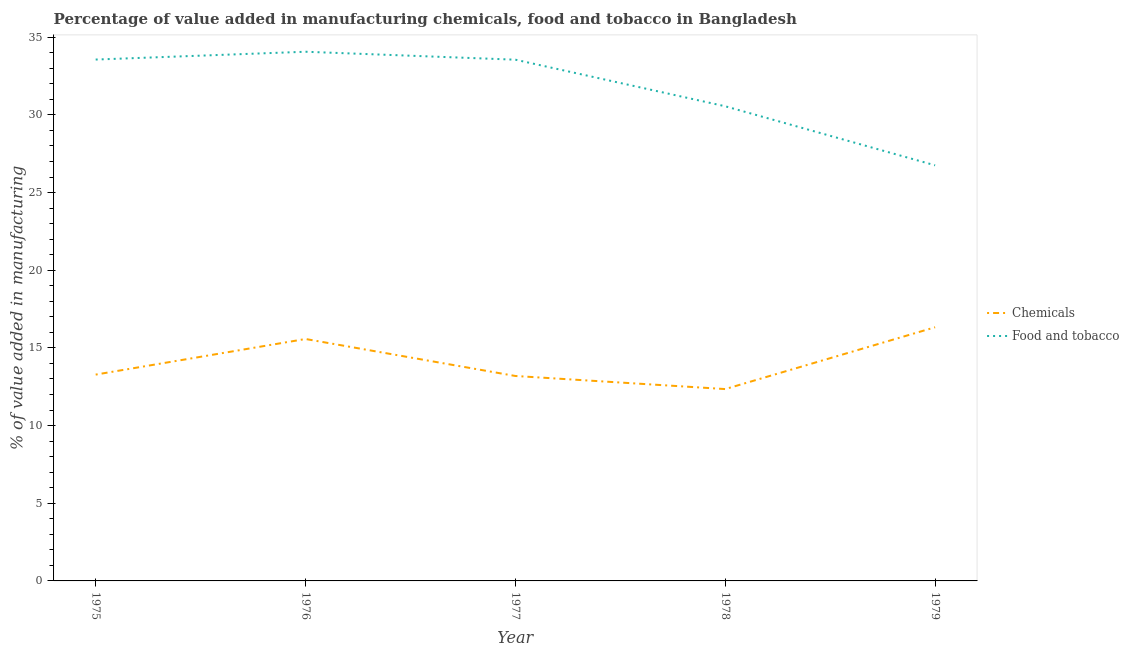What is the value added by  manufacturing chemicals in 1977?
Provide a succinct answer. 13.19. Across all years, what is the maximum value added by manufacturing food and tobacco?
Make the answer very short. 34.07. Across all years, what is the minimum value added by manufacturing food and tobacco?
Your answer should be very brief. 26.75. In which year was the value added by manufacturing food and tobacco maximum?
Your answer should be compact. 1976. In which year was the value added by manufacturing food and tobacco minimum?
Make the answer very short. 1979. What is the total value added by  manufacturing chemicals in the graph?
Provide a succinct answer. 70.73. What is the difference between the value added by manufacturing food and tobacco in 1975 and that in 1978?
Provide a succinct answer. 3.01. What is the difference between the value added by manufacturing food and tobacco in 1978 and the value added by  manufacturing chemicals in 1977?
Your response must be concise. 17.36. What is the average value added by  manufacturing chemicals per year?
Provide a succinct answer. 14.15. In the year 1976, what is the difference between the value added by  manufacturing chemicals and value added by manufacturing food and tobacco?
Ensure brevity in your answer.  -18.49. What is the ratio of the value added by manufacturing food and tobacco in 1977 to that in 1978?
Offer a very short reply. 1.1. Is the value added by manufacturing food and tobacco in 1976 less than that in 1977?
Your response must be concise. No. Is the difference between the value added by manufacturing food and tobacco in 1976 and 1978 greater than the difference between the value added by  manufacturing chemicals in 1976 and 1978?
Your answer should be very brief. Yes. What is the difference between the highest and the second highest value added by manufacturing food and tobacco?
Offer a terse response. 0.5. What is the difference between the highest and the lowest value added by manufacturing food and tobacco?
Your answer should be very brief. 7.31. In how many years, is the value added by  manufacturing chemicals greater than the average value added by  manufacturing chemicals taken over all years?
Your answer should be compact. 2. How many lines are there?
Your response must be concise. 2. Does the graph contain any zero values?
Provide a succinct answer. No. Does the graph contain grids?
Your answer should be compact. No. Where does the legend appear in the graph?
Keep it short and to the point. Center right. What is the title of the graph?
Your response must be concise. Percentage of value added in manufacturing chemicals, food and tobacco in Bangladesh. Does "Private funds" appear as one of the legend labels in the graph?
Your response must be concise. No. What is the label or title of the Y-axis?
Your response must be concise. % of value added in manufacturing. What is the % of value added in manufacturing in Chemicals in 1975?
Your answer should be very brief. 13.28. What is the % of value added in manufacturing of Food and tobacco in 1975?
Offer a terse response. 33.56. What is the % of value added in manufacturing of Chemicals in 1976?
Your response must be concise. 15.57. What is the % of value added in manufacturing in Food and tobacco in 1976?
Your answer should be very brief. 34.07. What is the % of value added in manufacturing in Chemicals in 1977?
Keep it short and to the point. 13.19. What is the % of value added in manufacturing of Food and tobacco in 1977?
Your response must be concise. 33.55. What is the % of value added in manufacturing of Chemicals in 1978?
Your answer should be compact. 12.35. What is the % of value added in manufacturing in Food and tobacco in 1978?
Make the answer very short. 30.56. What is the % of value added in manufacturing of Chemicals in 1979?
Provide a succinct answer. 16.33. What is the % of value added in manufacturing in Food and tobacco in 1979?
Give a very brief answer. 26.75. Across all years, what is the maximum % of value added in manufacturing of Chemicals?
Offer a terse response. 16.33. Across all years, what is the maximum % of value added in manufacturing of Food and tobacco?
Your answer should be very brief. 34.07. Across all years, what is the minimum % of value added in manufacturing in Chemicals?
Make the answer very short. 12.35. Across all years, what is the minimum % of value added in manufacturing of Food and tobacco?
Keep it short and to the point. 26.75. What is the total % of value added in manufacturing in Chemicals in the graph?
Your response must be concise. 70.73. What is the total % of value added in manufacturing in Food and tobacco in the graph?
Give a very brief answer. 158.49. What is the difference between the % of value added in manufacturing of Chemicals in 1975 and that in 1976?
Give a very brief answer. -2.29. What is the difference between the % of value added in manufacturing in Food and tobacco in 1975 and that in 1976?
Offer a very short reply. -0.5. What is the difference between the % of value added in manufacturing of Chemicals in 1975 and that in 1977?
Provide a succinct answer. 0.09. What is the difference between the % of value added in manufacturing in Food and tobacco in 1975 and that in 1977?
Give a very brief answer. 0.01. What is the difference between the % of value added in manufacturing in Chemicals in 1975 and that in 1978?
Provide a succinct answer. 0.93. What is the difference between the % of value added in manufacturing in Food and tobacco in 1975 and that in 1978?
Offer a very short reply. 3.01. What is the difference between the % of value added in manufacturing in Chemicals in 1975 and that in 1979?
Provide a short and direct response. -3.05. What is the difference between the % of value added in manufacturing in Food and tobacco in 1975 and that in 1979?
Your answer should be very brief. 6.81. What is the difference between the % of value added in manufacturing in Chemicals in 1976 and that in 1977?
Your answer should be compact. 2.38. What is the difference between the % of value added in manufacturing in Food and tobacco in 1976 and that in 1977?
Ensure brevity in your answer.  0.51. What is the difference between the % of value added in manufacturing in Chemicals in 1976 and that in 1978?
Keep it short and to the point. 3.22. What is the difference between the % of value added in manufacturing of Food and tobacco in 1976 and that in 1978?
Provide a short and direct response. 3.51. What is the difference between the % of value added in manufacturing in Chemicals in 1976 and that in 1979?
Keep it short and to the point. -0.76. What is the difference between the % of value added in manufacturing of Food and tobacco in 1976 and that in 1979?
Give a very brief answer. 7.31. What is the difference between the % of value added in manufacturing in Chemicals in 1977 and that in 1978?
Make the answer very short. 0.84. What is the difference between the % of value added in manufacturing in Food and tobacco in 1977 and that in 1978?
Your answer should be compact. 3. What is the difference between the % of value added in manufacturing of Chemicals in 1977 and that in 1979?
Provide a succinct answer. -3.14. What is the difference between the % of value added in manufacturing of Food and tobacco in 1977 and that in 1979?
Keep it short and to the point. 6.8. What is the difference between the % of value added in manufacturing in Chemicals in 1978 and that in 1979?
Make the answer very short. -3.98. What is the difference between the % of value added in manufacturing in Food and tobacco in 1978 and that in 1979?
Offer a terse response. 3.8. What is the difference between the % of value added in manufacturing of Chemicals in 1975 and the % of value added in manufacturing of Food and tobacco in 1976?
Offer a terse response. -20.78. What is the difference between the % of value added in manufacturing of Chemicals in 1975 and the % of value added in manufacturing of Food and tobacco in 1977?
Provide a short and direct response. -20.27. What is the difference between the % of value added in manufacturing of Chemicals in 1975 and the % of value added in manufacturing of Food and tobacco in 1978?
Ensure brevity in your answer.  -17.27. What is the difference between the % of value added in manufacturing of Chemicals in 1975 and the % of value added in manufacturing of Food and tobacco in 1979?
Give a very brief answer. -13.47. What is the difference between the % of value added in manufacturing in Chemicals in 1976 and the % of value added in manufacturing in Food and tobacco in 1977?
Make the answer very short. -17.98. What is the difference between the % of value added in manufacturing in Chemicals in 1976 and the % of value added in manufacturing in Food and tobacco in 1978?
Your answer should be compact. -14.98. What is the difference between the % of value added in manufacturing of Chemicals in 1976 and the % of value added in manufacturing of Food and tobacco in 1979?
Offer a very short reply. -11.18. What is the difference between the % of value added in manufacturing of Chemicals in 1977 and the % of value added in manufacturing of Food and tobacco in 1978?
Provide a short and direct response. -17.36. What is the difference between the % of value added in manufacturing in Chemicals in 1977 and the % of value added in manufacturing in Food and tobacco in 1979?
Provide a short and direct response. -13.56. What is the difference between the % of value added in manufacturing in Chemicals in 1978 and the % of value added in manufacturing in Food and tobacco in 1979?
Keep it short and to the point. -14.4. What is the average % of value added in manufacturing of Chemicals per year?
Give a very brief answer. 14.15. What is the average % of value added in manufacturing in Food and tobacco per year?
Keep it short and to the point. 31.7. In the year 1975, what is the difference between the % of value added in manufacturing in Chemicals and % of value added in manufacturing in Food and tobacco?
Make the answer very short. -20.28. In the year 1976, what is the difference between the % of value added in manufacturing of Chemicals and % of value added in manufacturing of Food and tobacco?
Offer a terse response. -18.49. In the year 1977, what is the difference between the % of value added in manufacturing of Chemicals and % of value added in manufacturing of Food and tobacco?
Your response must be concise. -20.36. In the year 1978, what is the difference between the % of value added in manufacturing in Chemicals and % of value added in manufacturing in Food and tobacco?
Offer a very short reply. -18.21. In the year 1979, what is the difference between the % of value added in manufacturing of Chemicals and % of value added in manufacturing of Food and tobacco?
Your answer should be compact. -10.42. What is the ratio of the % of value added in manufacturing of Chemicals in 1975 to that in 1976?
Your answer should be compact. 0.85. What is the ratio of the % of value added in manufacturing in Food and tobacco in 1975 to that in 1976?
Ensure brevity in your answer.  0.99. What is the ratio of the % of value added in manufacturing in Chemicals in 1975 to that in 1977?
Keep it short and to the point. 1.01. What is the ratio of the % of value added in manufacturing of Chemicals in 1975 to that in 1978?
Offer a very short reply. 1.08. What is the ratio of the % of value added in manufacturing in Food and tobacco in 1975 to that in 1978?
Your answer should be compact. 1.1. What is the ratio of the % of value added in manufacturing in Chemicals in 1975 to that in 1979?
Keep it short and to the point. 0.81. What is the ratio of the % of value added in manufacturing of Food and tobacco in 1975 to that in 1979?
Keep it short and to the point. 1.25. What is the ratio of the % of value added in manufacturing of Chemicals in 1976 to that in 1977?
Offer a terse response. 1.18. What is the ratio of the % of value added in manufacturing in Food and tobacco in 1976 to that in 1977?
Offer a terse response. 1.02. What is the ratio of the % of value added in manufacturing in Chemicals in 1976 to that in 1978?
Your response must be concise. 1.26. What is the ratio of the % of value added in manufacturing of Food and tobacco in 1976 to that in 1978?
Your response must be concise. 1.11. What is the ratio of the % of value added in manufacturing in Chemicals in 1976 to that in 1979?
Your response must be concise. 0.95. What is the ratio of the % of value added in manufacturing in Food and tobacco in 1976 to that in 1979?
Your answer should be very brief. 1.27. What is the ratio of the % of value added in manufacturing in Chemicals in 1977 to that in 1978?
Your response must be concise. 1.07. What is the ratio of the % of value added in manufacturing in Food and tobacco in 1977 to that in 1978?
Ensure brevity in your answer.  1.1. What is the ratio of the % of value added in manufacturing of Chemicals in 1977 to that in 1979?
Your answer should be compact. 0.81. What is the ratio of the % of value added in manufacturing in Food and tobacco in 1977 to that in 1979?
Offer a very short reply. 1.25. What is the ratio of the % of value added in manufacturing of Chemicals in 1978 to that in 1979?
Offer a very short reply. 0.76. What is the ratio of the % of value added in manufacturing in Food and tobacco in 1978 to that in 1979?
Keep it short and to the point. 1.14. What is the difference between the highest and the second highest % of value added in manufacturing in Chemicals?
Your response must be concise. 0.76. What is the difference between the highest and the second highest % of value added in manufacturing of Food and tobacco?
Your answer should be very brief. 0.5. What is the difference between the highest and the lowest % of value added in manufacturing in Chemicals?
Your answer should be compact. 3.98. What is the difference between the highest and the lowest % of value added in manufacturing of Food and tobacco?
Your answer should be compact. 7.31. 